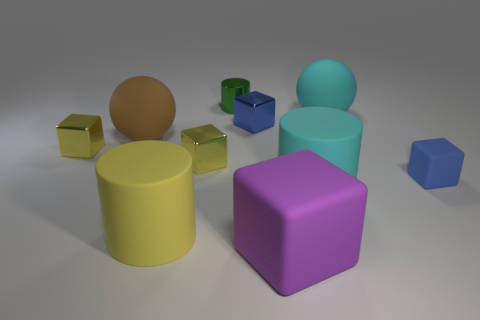Subtract all purple cylinders. How many blue cubes are left? 2 Subtract all big rubber cubes. How many cubes are left? 4 Subtract 2 blocks. How many blocks are left? 3 Subtract all purple cubes. How many cubes are left? 4 Subtract all brown cylinders. Subtract all purple balls. How many cylinders are left? 3 Subtract all spheres. How many objects are left? 8 Add 1 matte cylinders. How many matte cylinders exist? 3 Subtract 0 purple spheres. How many objects are left? 10 Subtract all large cyan things. Subtract all blue metallic cubes. How many objects are left? 7 Add 7 tiny green objects. How many tiny green objects are left? 8 